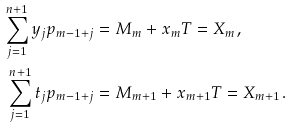Convert formula to latex. <formula><loc_0><loc_0><loc_500><loc_500>\sum _ { j = 1 } ^ { n + 1 } y _ { j } p _ { m - 1 + j } & = M _ { m } + x _ { m } T = X _ { m } , \\ \sum _ { j = 1 } ^ { n + 1 } t _ { j } p _ { m - 1 + j } & = M _ { m + 1 } + x _ { m + 1 } T = X _ { m + 1 } .</formula> 